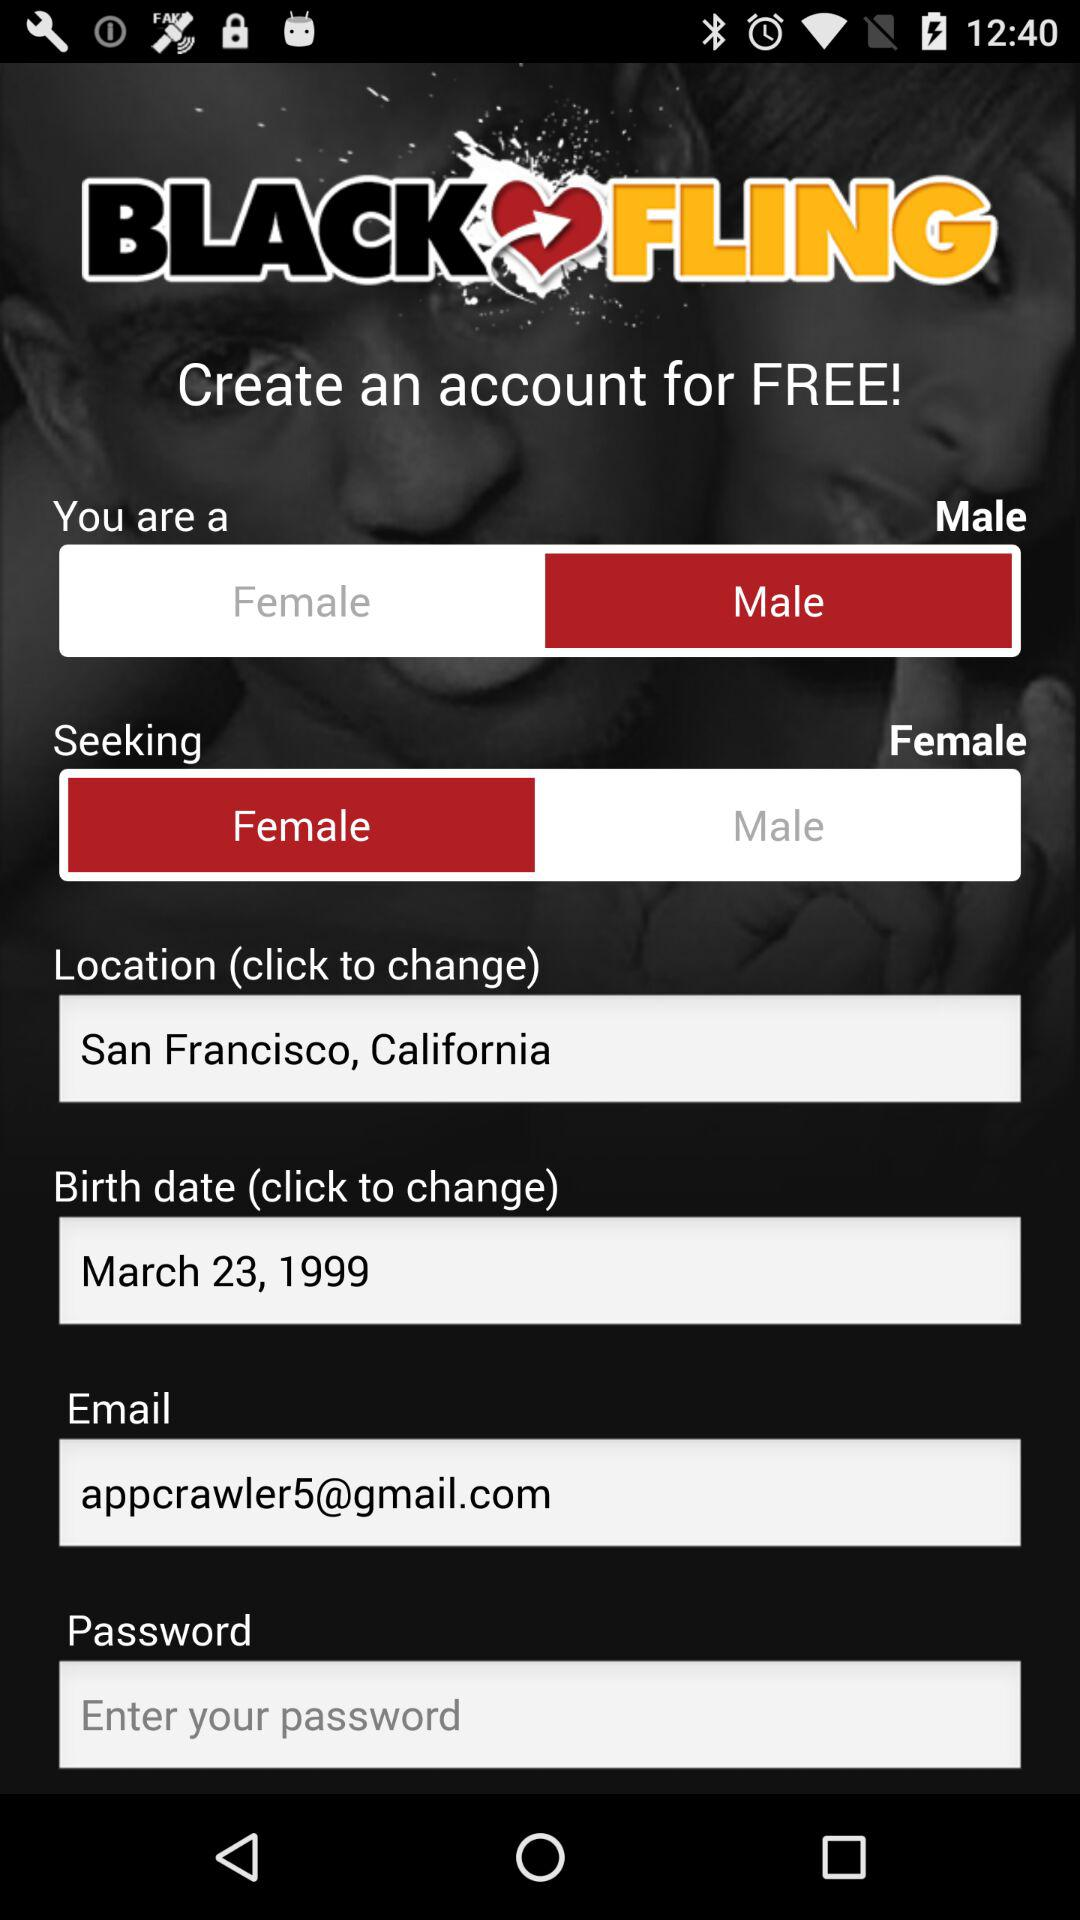What is the email address? The email address is appcrawler5@gmail.com. 